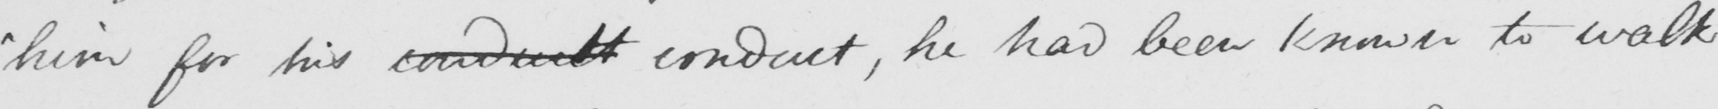Please transcribe the handwritten text in this image. " him for his conduilt conduct , he had been known to walk 